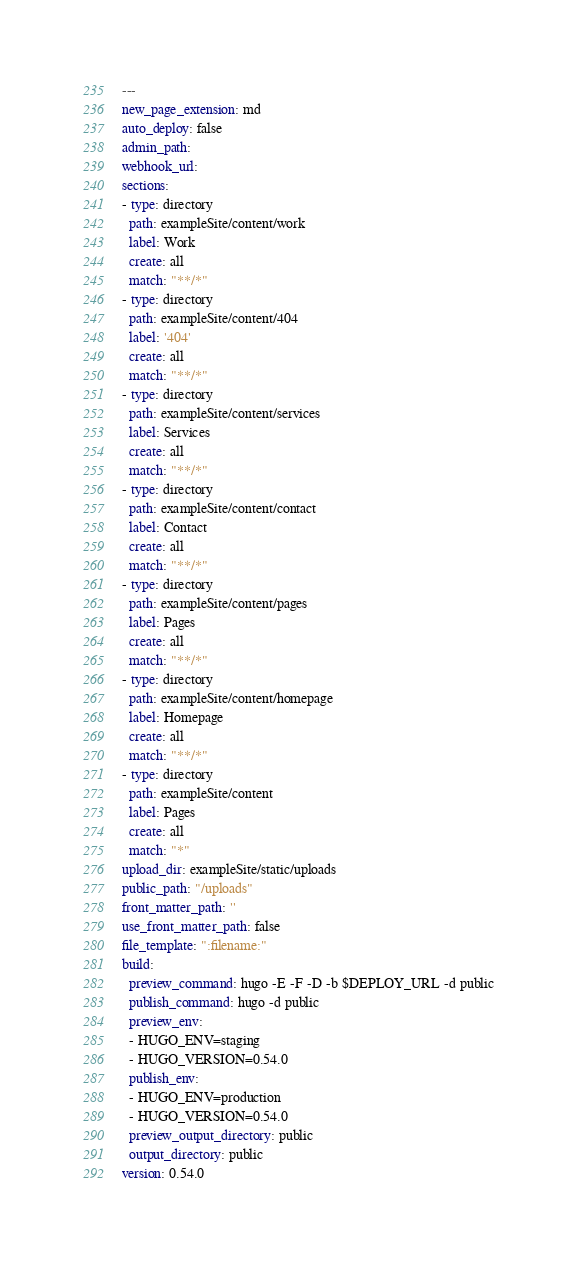<code> <loc_0><loc_0><loc_500><loc_500><_YAML_>---
new_page_extension: md
auto_deploy: false
admin_path: 
webhook_url: 
sections:
- type: directory
  path: exampleSite/content/work
  label: Work
  create: all
  match: "**/*"
- type: directory
  path: exampleSite/content/404
  label: '404'
  create: all
  match: "**/*"
- type: directory
  path: exampleSite/content/services
  label: Services
  create: all
  match: "**/*"
- type: directory
  path: exampleSite/content/contact
  label: Contact
  create: all
  match: "**/*"
- type: directory
  path: exampleSite/content/pages
  label: Pages
  create: all
  match: "**/*"
- type: directory
  path: exampleSite/content/homepage
  label: Homepage
  create: all
  match: "**/*"
- type: directory
  path: exampleSite/content
  label: Pages
  create: all
  match: "*"
upload_dir: exampleSite/static/uploads
public_path: "/uploads"
front_matter_path: ''
use_front_matter_path: false
file_template: ":filename:"
build:
  preview_command: hugo -E -F -D -b $DEPLOY_URL -d public
  publish_command: hugo -d public
  preview_env:
  - HUGO_ENV=staging
  - HUGO_VERSION=0.54.0
  publish_env:
  - HUGO_ENV=production
  - HUGO_VERSION=0.54.0
  preview_output_directory: public
  output_directory: public
version: 0.54.0
</code> 